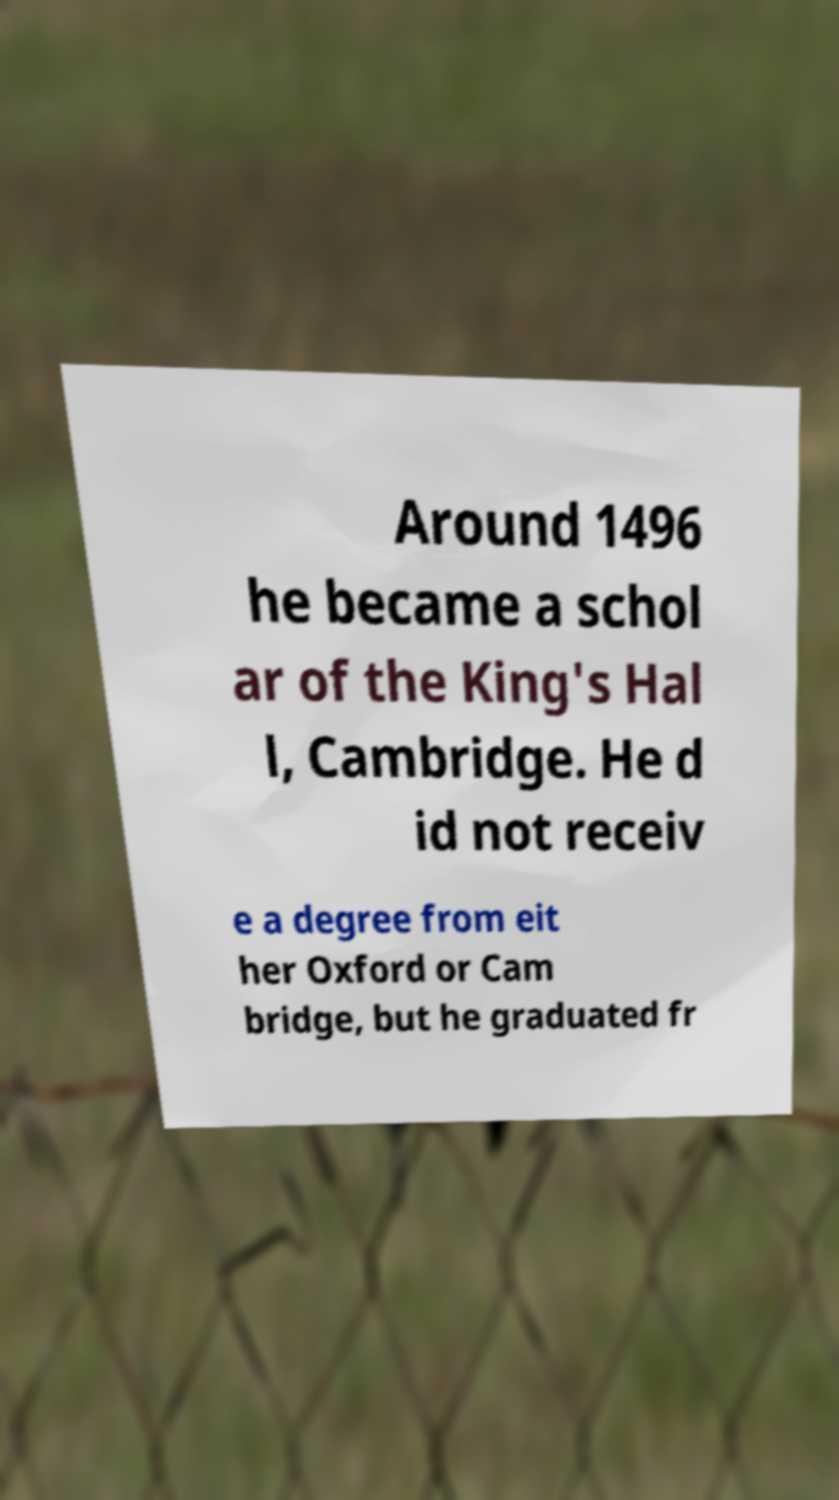Please identify and transcribe the text found in this image. Around 1496 he became a schol ar of the King's Hal l, Cambridge. He d id not receiv e a degree from eit her Oxford or Cam bridge, but he graduated fr 